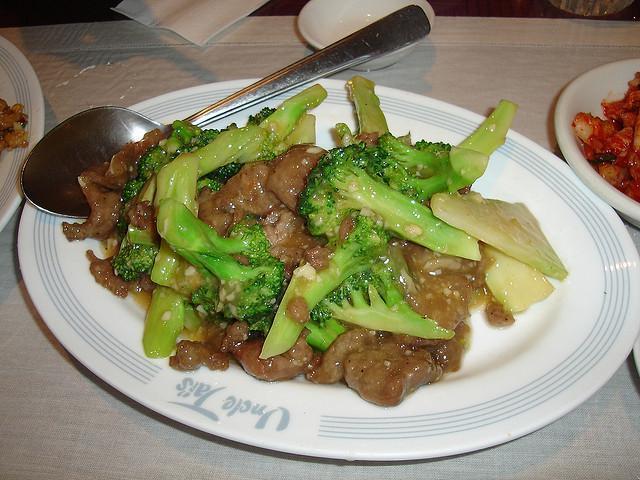How many dining tables are there?
Give a very brief answer. 1. How many broccolis are there?
Give a very brief answer. 8. How many spoons are visible?
Give a very brief answer. 1. How many bowls can you see?
Give a very brief answer. 2. How many people are wearing a face mask?
Give a very brief answer. 0. 